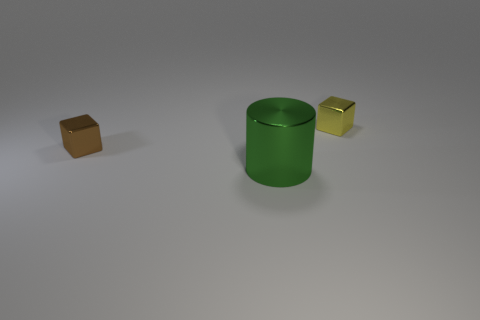What is the shape of the green thing?
Keep it short and to the point. Cylinder. Are there more tiny cubes to the left of the green object than cylinders that are left of the small brown shiny thing?
Provide a short and direct response. Yes. There is a yellow thing; does it have the same shape as the tiny object that is in front of the small yellow block?
Provide a short and direct response. Yes. There is a thing that is left of the large green shiny cylinder; is its size the same as the metal object right of the big green shiny cylinder?
Ensure brevity in your answer.  Yes. There is a small object that is left of the small block behind the brown metal cube; is there a block that is behind it?
Give a very brief answer. Yes. Are there fewer yellow blocks on the right side of the small yellow cube than yellow metallic cubes that are behind the shiny cylinder?
Keep it short and to the point. Yes. There is a small brown thing that is made of the same material as the small yellow thing; what shape is it?
Your answer should be very brief. Cube. How big is the block behind the small cube that is in front of the small shiny thing right of the tiny brown shiny thing?
Provide a succinct answer. Small. Is the number of tiny brown cubes greater than the number of small green matte blocks?
Your response must be concise. Yes. There is a small thing behind the tiny brown cube; is its color the same as the tiny metallic object that is left of the large green metal thing?
Your response must be concise. No. 